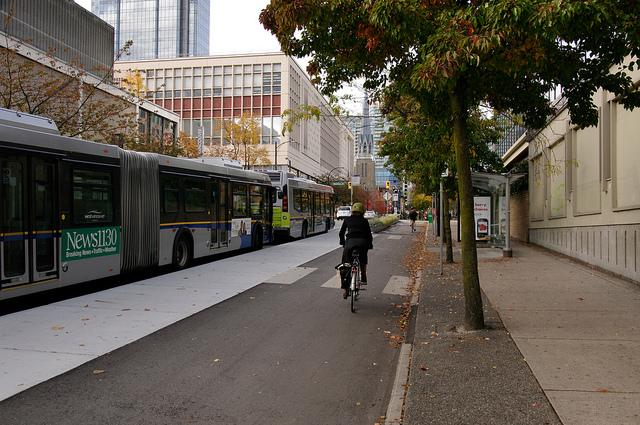What type of lane is shown? Please explain your reasoning. bike. This is a narrow lane and people are riding bikes on it. 